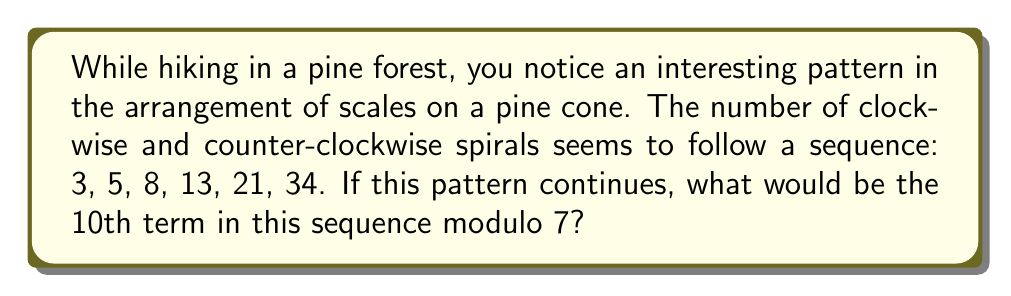Give your solution to this math problem. Let's break this down step-by-step:

1) First, we need to recognize that the given sequence is a Fibonacci sequence. In the Fibonacci sequence, each number is the sum of the two preceding ones.

2) Let's continue the sequence to the 10th term:
   3, 5, 8, 13, 21, 34, 55, 89, 144, 233

3) The 10th term is 233.

4) Now, we need to find 233 modulo 7. In modular arithmetic, this is equivalent to finding the remainder when 233 is divided by 7.

5) We can do this division:
   $$ 233 = 33 \times 7 + 2 $$

6) Therefore, 233 ≡ 2 (mod 7)

This means that when we divide 233 by 7, the remainder is 2.

In terms of pine cone growth, this could represent a cyclic pattern in the arrangement of scales that repeats every 7 steps in the Fibonacci sequence.
Answer: 2 